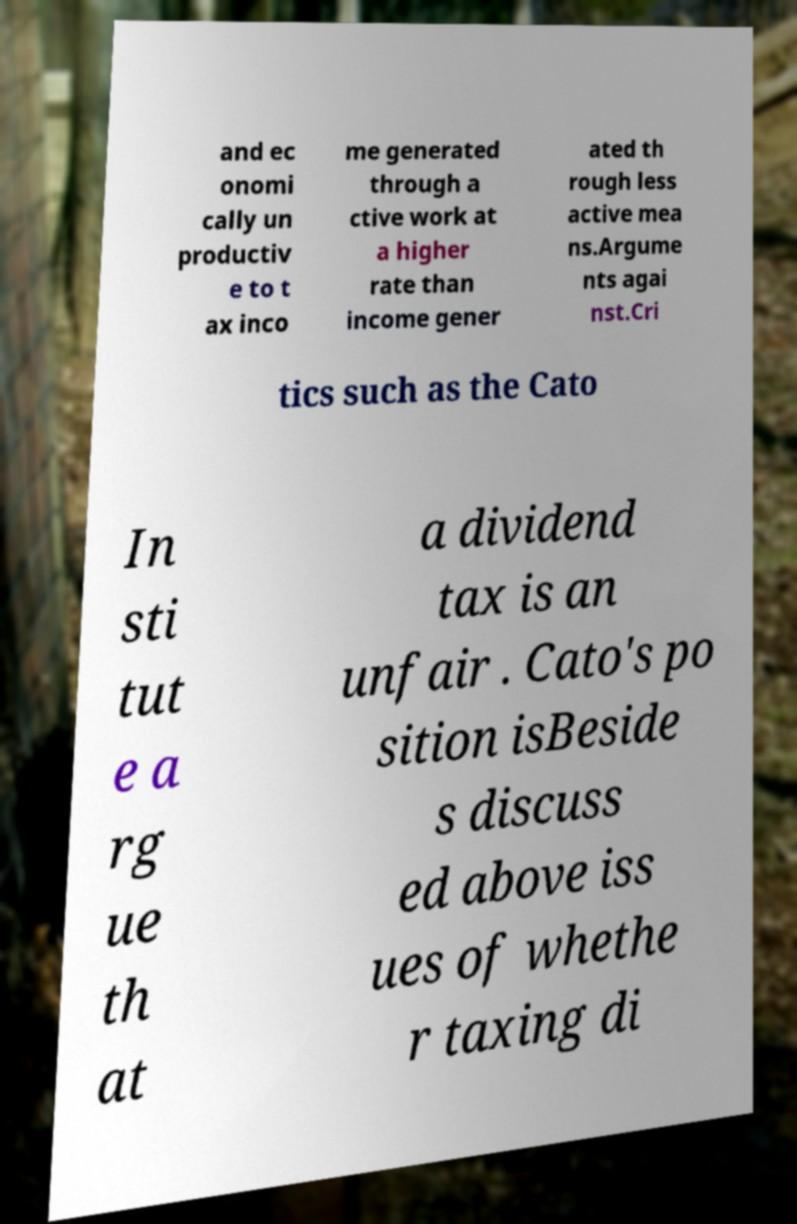For documentation purposes, I need the text within this image transcribed. Could you provide that? and ec onomi cally un productiv e to t ax inco me generated through a ctive work at a higher rate than income gener ated th rough less active mea ns.Argume nts agai nst.Cri tics such as the Cato In sti tut e a rg ue th at a dividend tax is an unfair . Cato's po sition isBeside s discuss ed above iss ues of whethe r taxing di 